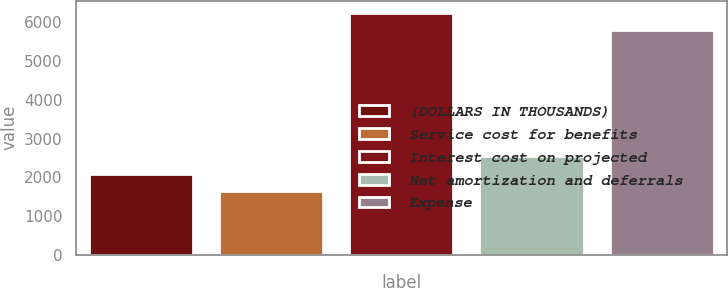Convert chart to OTSL. <chart><loc_0><loc_0><loc_500><loc_500><bar_chart><fcel>(DOLLARS IN THOUSANDS)<fcel>Service cost for benefits<fcel>Interest cost on projected<fcel>Net amortization and deferrals<fcel>Expense<nl><fcel>2096.2<fcel>1644<fcel>6250.2<fcel>2548.4<fcel>5798<nl></chart> 